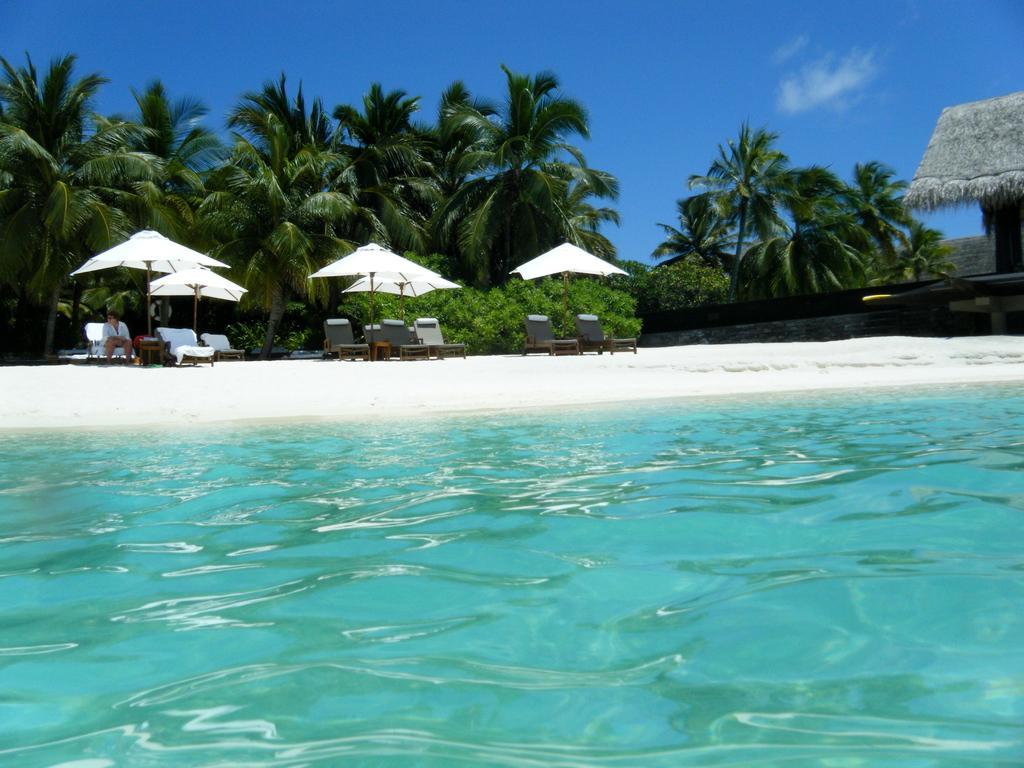Please provide a concise description of this image. In this image I can see water in the front. In the background I can see few chairs, few white colour umbrellas, number of trees, clouds, the sky and on the left side I can see one person is sitting on a chair. I can also see a shack on the right side of the image. 